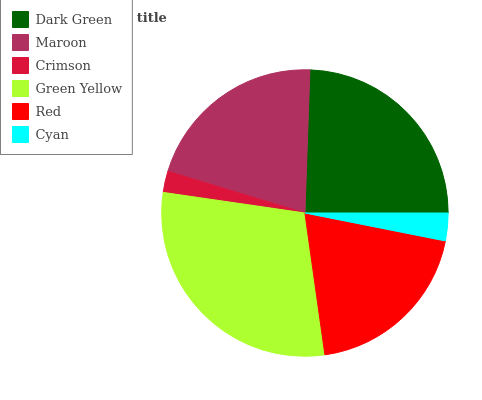Is Crimson the minimum?
Answer yes or no. Yes. Is Green Yellow the maximum?
Answer yes or no. Yes. Is Maroon the minimum?
Answer yes or no. No. Is Maroon the maximum?
Answer yes or no. No. Is Dark Green greater than Maroon?
Answer yes or no. Yes. Is Maroon less than Dark Green?
Answer yes or no. Yes. Is Maroon greater than Dark Green?
Answer yes or no. No. Is Dark Green less than Maroon?
Answer yes or no. No. Is Maroon the high median?
Answer yes or no. Yes. Is Red the low median?
Answer yes or no. Yes. Is Green Yellow the high median?
Answer yes or no. No. Is Cyan the low median?
Answer yes or no. No. 